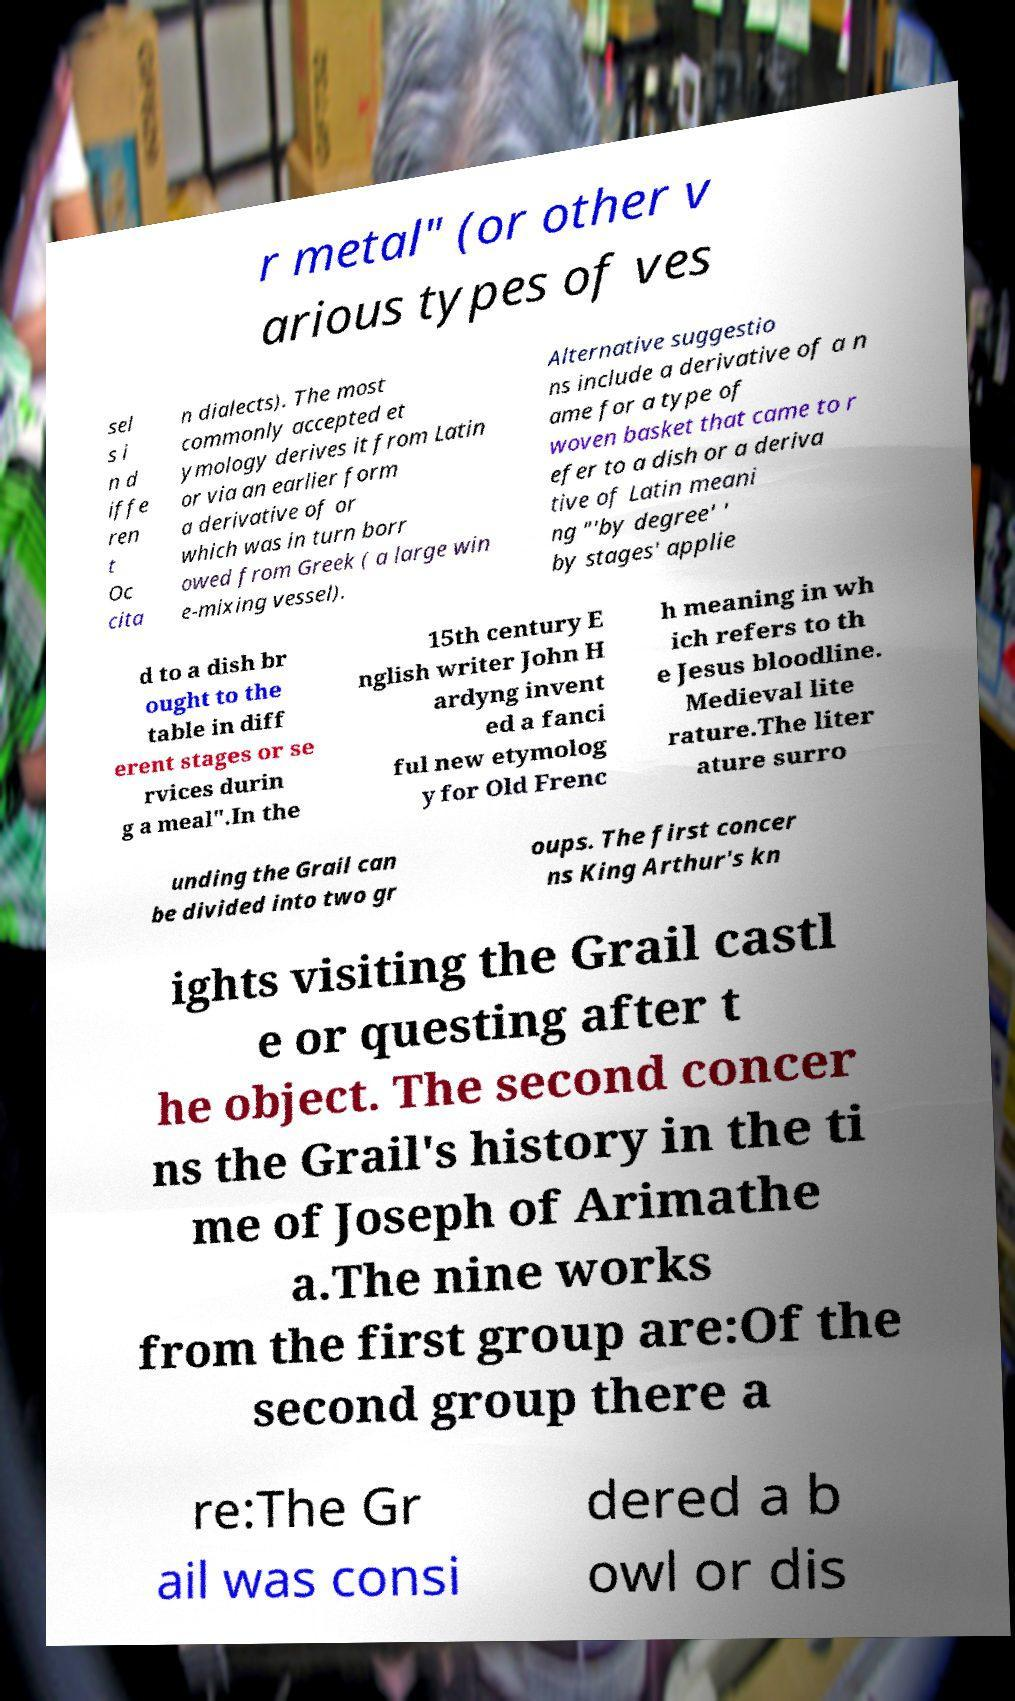What messages or text are displayed in this image? I need them in a readable, typed format. r metal" (or other v arious types of ves sel s i n d iffe ren t Oc cita n dialects). The most commonly accepted et ymology derives it from Latin or via an earlier form a derivative of or which was in turn borr owed from Greek ( a large win e-mixing vessel). Alternative suggestio ns include a derivative of a n ame for a type of woven basket that came to r efer to a dish or a deriva tive of Latin meani ng "'by degree' ' by stages' applie d to a dish br ought to the table in diff erent stages or se rvices durin g a meal".In the 15th century E nglish writer John H ardyng invent ed a fanci ful new etymolog y for Old Frenc h meaning in wh ich refers to th e Jesus bloodline. Medieval lite rature.The liter ature surro unding the Grail can be divided into two gr oups. The first concer ns King Arthur's kn ights visiting the Grail castl e or questing after t he object. The second concer ns the Grail's history in the ti me of Joseph of Arimathe a.The nine works from the first group are:Of the second group there a re:The Gr ail was consi dered a b owl or dis 